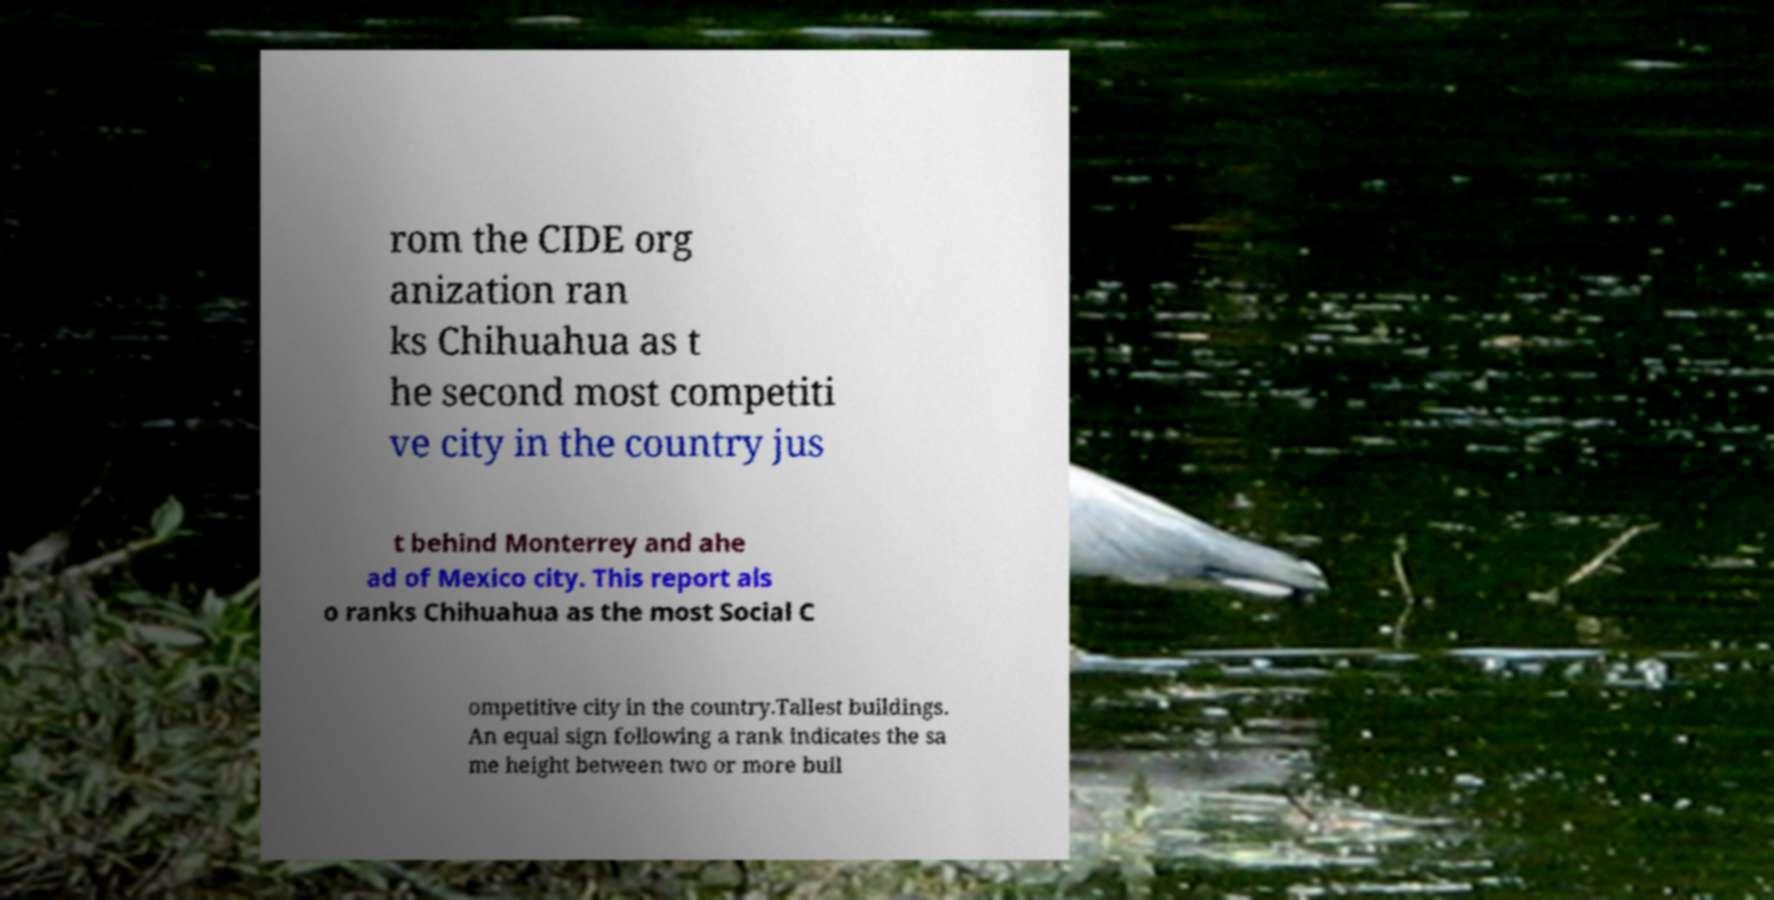Can you read and provide the text displayed in the image?This photo seems to have some interesting text. Can you extract and type it out for me? rom the CIDE org anization ran ks Chihuahua as t he second most competiti ve city in the country jus t behind Monterrey and ahe ad of Mexico city. This report als o ranks Chihuahua as the most Social C ompetitive city in the country.Tallest buildings. An equal sign following a rank indicates the sa me height between two or more buil 